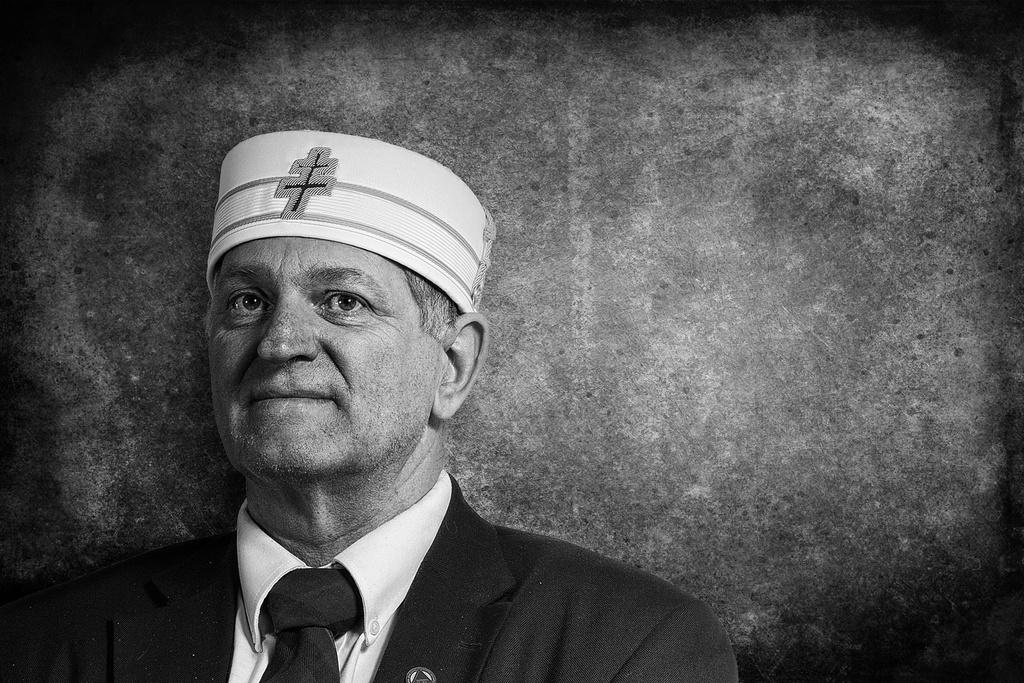What is the color scheme of the image? The image is black and white. Can you describe the person in the image? The person is wearing a blazer and a cap. What is behind the person in the image? There is a wall behind the person. Is there a cactus growing on the wall behind the person in the image? No, there is no cactus visible in the image. Can you tell me who the father of the person in the image is? The provided facts do not give any information about the person's family, so we cannot determine their father from the image. 